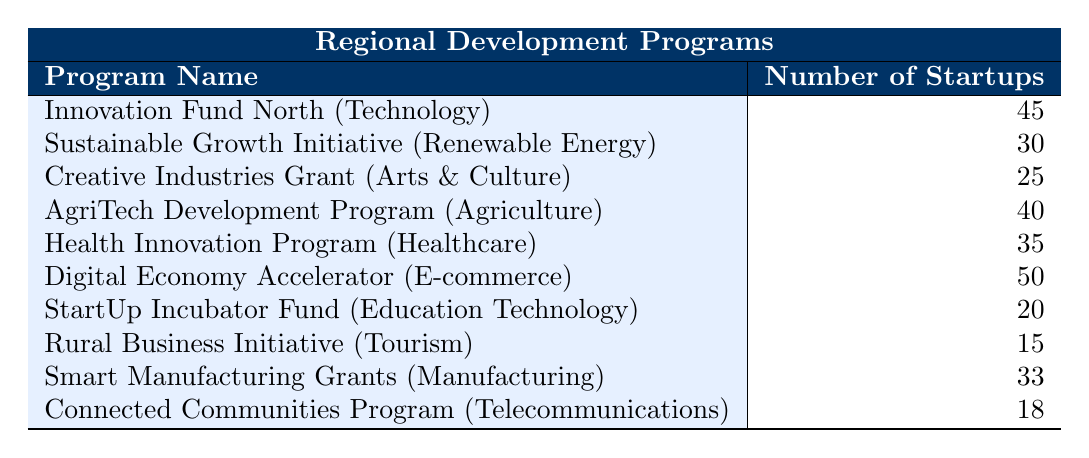What is the total number of startups supported in the Technology industry? From the table, we see that the "Innovation Fund North" supports 45 startups in the Technology industry. Therefore, we can conclude that the total number of startups supported in this industry is simply 45.
Answer: 45 Which program supports the highest number of startups? Looking through the table, the "Digital Economy Accelerator" has the highest number of supported startups at 50. This indicates that it is the most impactful program in terms of startup support.
Answer: Digital Economy Accelerator Is the number of startups supported by the Sustainable Growth Initiative greater than 25? The table shows that the "Sustainable Growth Initiative" supports 30 startups. Since 30 is greater than 25, the answer is affirmative.
Answer: Yes What is the difference in the number of startups supported between the Health Innovation Program and the AgriTech Development Program? The "Health Innovation Program" supports 35 startups and the "AgriTech Development Program" supports 40 startups. The difference is calculated as 40 - 35 = 5.
Answer: 5 Which industry received the least support and how many startups were funded? Reviewing the table, the "Rural Business Initiative" under the Tourism industry has the least support with only 15 startups funded. Therefore, this indicates it is the lowest in terms of startup support.
Answer: Tourism industry, 15 startups What is the average number of startups supported across all programs? To find the average, we sum the number of startups supported: 45 + 30 + 25 + 40 + 35 + 50 + 20 + 15 + 33 + 18 =  391. There are 10 programs in total, so the average is calculated as 391 / 10 = 39.1.
Answer: 39.1 Is it true that the Creative Industries Grant supports more startups than the Digital Economy Accelerator? The table indicates that the "Creative Industries Grant" supports 25 startups and the "Digital Economy Accelerator" supports 50 startups. Since 25 is not greater than 50, the statement is false.
Answer: No How many startups are supported by programs related to E-commerce and Telecommunications combined? The "Digital Economy Accelerator" which is related to E-commerce supports 50 startups, and the "Connected Communities Program" related to Telecommunications supports 18 startups. Adding them together gives 50 + 18 = 68 startups supported combined.
Answer: 68 Which industry has more support: Agriculture or Healthcare? According to the data, the "AgriTech Development Program" supports 40 startups in Agriculture while the "Health Innovation Program" supports 35 startups in Healthcare. Since 40 is greater than 35, Agriculture has more support.
Answer: Agriculture 